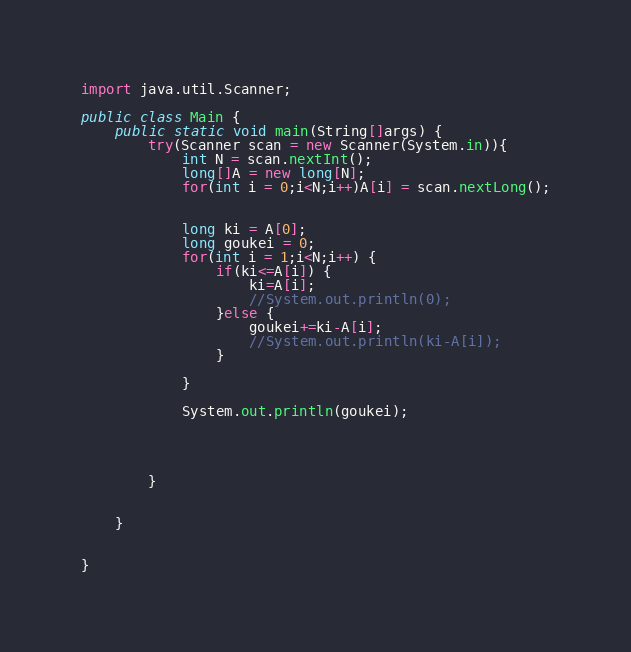Convert code to text. <code><loc_0><loc_0><loc_500><loc_500><_Java_>import java.util.Scanner;

public class Main {
	public static void main(String[]args) {
		try(Scanner scan = new Scanner(System.in)){
			int N = scan.nextInt();
			long[]A = new long[N];
			for(int i = 0;i<N;i++)A[i] = scan.nextLong();


			long ki = A[0];
			long goukei = 0;
			for(int i = 1;i<N;i++) {
				if(ki<=A[i]) {
					ki=A[i];
					//System.out.println(0);
				}else {
					goukei+=ki-A[i];
					//System.out.println(ki-A[i]);
				}

			}

			System.out.println(goukei);




		}


	}


}
</code> 